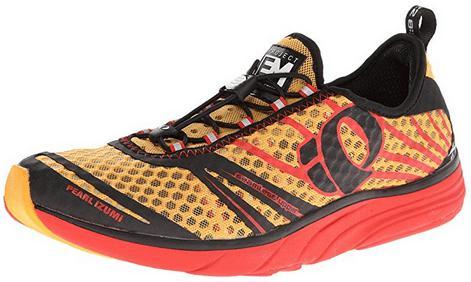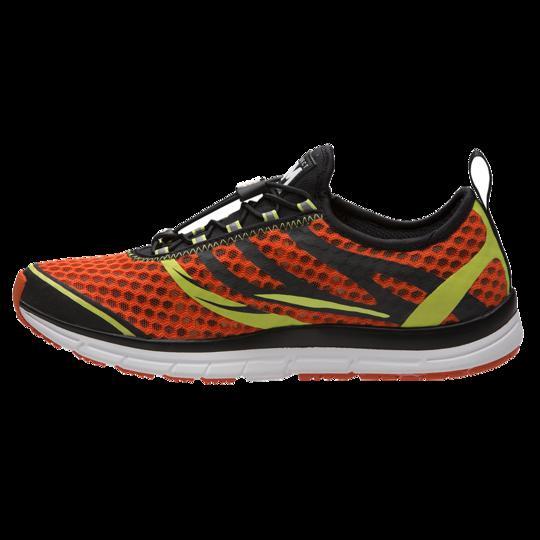The first image is the image on the left, the second image is the image on the right. For the images shown, is this caption "Each image contains a single sneaker, and the sneakers in the left and right images face different [left vs right] directions." true? Answer yes or no. No. The first image is the image on the left, the second image is the image on the right. Examine the images to the left and right. Is the description "A single shoe sits on a white surface in each of the images." accurate? Answer yes or no. No. 